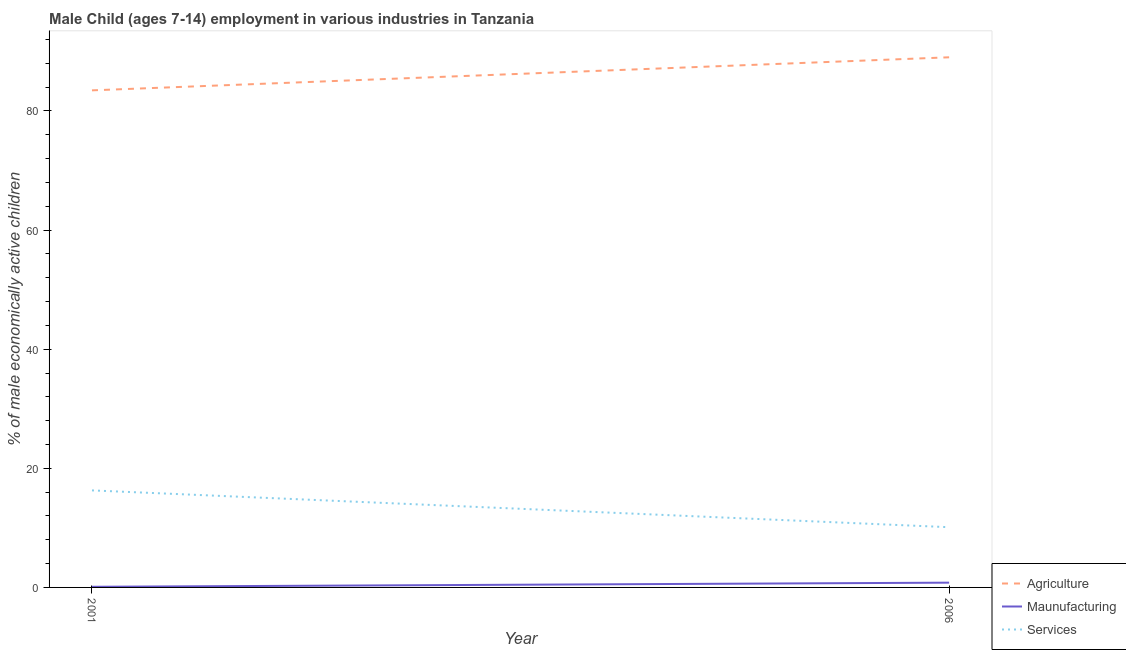How many different coloured lines are there?
Keep it short and to the point. 3. Does the line corresponding to percentage of economically active children in services intersect with the line corresponding to percentage of economically active children in agriculture?
Offer a very short reply. No. What is the percentage of economically active children in agriculture in 2006?
Keep it short and to the point. 89.01. Across all years, what is the maximum percentage of economically active children in services?
Provide a short and direct response. 16.29. Across all years, what is the minimum percentage of economically active children in services?
Provide a short and direct response. 10.11. In which year was the percentage of economically active children in agriculture maximum?
Offer a very short reply. 2006. In which year was the percentage of economically active children in agriculture minimum?
Offer a terse response. 2001. What is the total percentage of economically active children in agriculture in the graph?
Keep it short and to the point. 172.47. What is the difference between the percentage of economically active children in manufacturing in 2001 and that in 2006?
Give a very brief answer. -0.69. What is the difference between the percentage of economically active children in agriculture in 2006 and the percentage of economically active children in services in 2001?
Your answer should be very brief. 72.72. What is the average percentage of economically active children in services per year?
Your answer should be very brief. 13.2. In the year 2001, what is the difference between the percentage of economically active children in manufacturing and percentage of economically active children in services?
Your response must be concise. -16.18. In how many years, is the percentage of economically active children in agriculture greater than 72 %?
Provide a succinct answer. 2. What is the ratio of the percentage of economically active children in services in 2001 to that in 2006?
Offer a terse response. 1.61. In how many years, is the percentage of economically active children in services greater than the average percentage of economically active children in services taken over all years?
Provide a short and direct response. 1. Does the percentage of economically active children in agriculture monotonically increase over the years?
Offer a very short reply. Yes. Is the percentage of economically active children in manufacturing strictly greater than the percentage of economically active children in services over the years?
Offer a very short reply. No. Is the percentage of economically active children in services strictly less than the percentage of economically active children in manufacturing over the years?
Your response must be concise. No. Where does the legend appear in the graph?
Offer a very short reply. Bottom right. What is the title of the graph?
Keep it short and to the point. Male Child (ages 7-14) employment in various industries in Tanzania. What is the label or title of the Y-axis?
Provide a short and direct response. % of male economically active children. What is the % of male economically active children of Agriculture in 2001?
Ensure brevity in your answer.  83.46. What is the % of male economically active children in Maunufacturing in 2001?
Offer a terse response. 0.11. What is the % of male economically active children in Services in 2001?
Ensure brevity in your answer.  16.29. What is the % of male economically active children of Agriculture in 2006?
Provide a short and direct response. 89.01. What is the % of male economically active children of Services in 2006?
Provide a succinct answer. 10.11. Across all years, what is the maximum % of male economically active children in Agriculture?
Your answer should be very brief. 89.01. Across all years, what is the maximum % of male economically active children in Services?
Ensure brevity in your answer.  16.29. Across all years, what is the minimum % of male economically active children in Agriculture?
Provide a succinct answer. 83.46. Across all years, what is the minimum % of male economically active children in Maunufacturing?
Your answer should be compact. 0.11. Across all years, what is the minimum % of male economically active children of Services?
Provide a short and direct response. 10.11. What is the total % of male economically active children in Agriculture in the graph?
Make the answer very short. 172.47. What is the total % of male economically active children in Maunufacturing in the graph?
Provide a succinct answer. 0.91. What is the total % of male economically active children of Services in the graph?
Offer a terse response. 26.4. What is the difference between the % of male economically active children of Agriculture in 2001 and that in 2006?
Your answer should be very brief. -5.55. What is the difference between the % of male economically active children in Maunufacturing in 2001 and that in 2006?
Your answer should be very brief. -0.69. What is the difference between the % of male economically active children in Services in 2001 and that in 2006?
Your answer should be very brief. 6.18. What is the difference between the % of male economically active children of Agriculture in 2001 and the % of male economically active children of Maunufacturing in 2006?
Your answer should be compact. 82.66. What is the difference between the % of male economically active children of Agriculture in 2001 and the % of male economically active children of Services in 2006?
Your response must be concise. 73.35. What is the difference between the % of male economically active children in Maunufacturing in 2001 and the % of male economically active children in Services in 2006?
Keep it short and to the point. -10. What is the average % of male economically active children of Agriculture per year?
Provide a short and direct response. 86.23. What is the average % of male economically active children of Maunufacturing per year?
Offer a very short reply. 0.45. What is the average % of male economically active children in Services per year?
Offer a terse response. 13.2. In the year 2001, what is the difference between the % of male economically active children of Agriculture and % of male economically active children of Maunufacturing?
Provide a short and direct response. 83.35. In the year 2001, what is the difference between the % of male economically active children of Agriculture and % of male economically active children of Services?
Ensure brevity in your answer.  67.17. In the year 2001, what is the difference between the % of male economically active children in Maunufacturing and % of male economically active children in Services?
Your answer should be compact. -16.18. In the year 2006, what is the difference between the % of male economically active children of Agriculture and % of male economically active children of Maunufacturing?
Your answer should be very brief. 88.21. In the year 2006, what is the difference between the % of male economically active children in Agriculture and % of male economically active children in Services?
Give a very brief answer. 78.9. In the year 2006, what is the difference between the % of male economically active children of Maunufacturing and % of male economically active children of Services?
Provide a succinct answer. -9.31. What is the ratio of the % of male economically active children of Agriculture in 2001 to that in 2006?
Your answer should be compact. 0.94. What is the ratio of the % of male economically active children in Maunufacturing in 2001 to that in 2006?
Keep it short and to the point. 0.13. What is the ratio of the % of male economically active children of Services in 2001 to that in 2006?
Provide a short and direct response. 1.61. What is the difference between the highest and the second highest % of male economically active children in Agriculture?
Keep it short and to the point. 5.55. What is the difference between the highest and the second highest % of male economically active children in Maunufacturing?
Keep it short and to the point. 0.69. What is the difference between the highest and the second highest % of male economically active children of Services?
Offer a terse response. 6.18. What is the difference between the highest and the lowest % of male economically active children of Agriculture?
Provide a short and direct response. 5.55. What is the difference between the highest and the lowest % of male economically active children of Maunufacturing?
Provide a succinct answer. 0.69. What is the difference between the highest and the lowest % of male economically active children of Services?
Your answer should be compact. 6.18. 